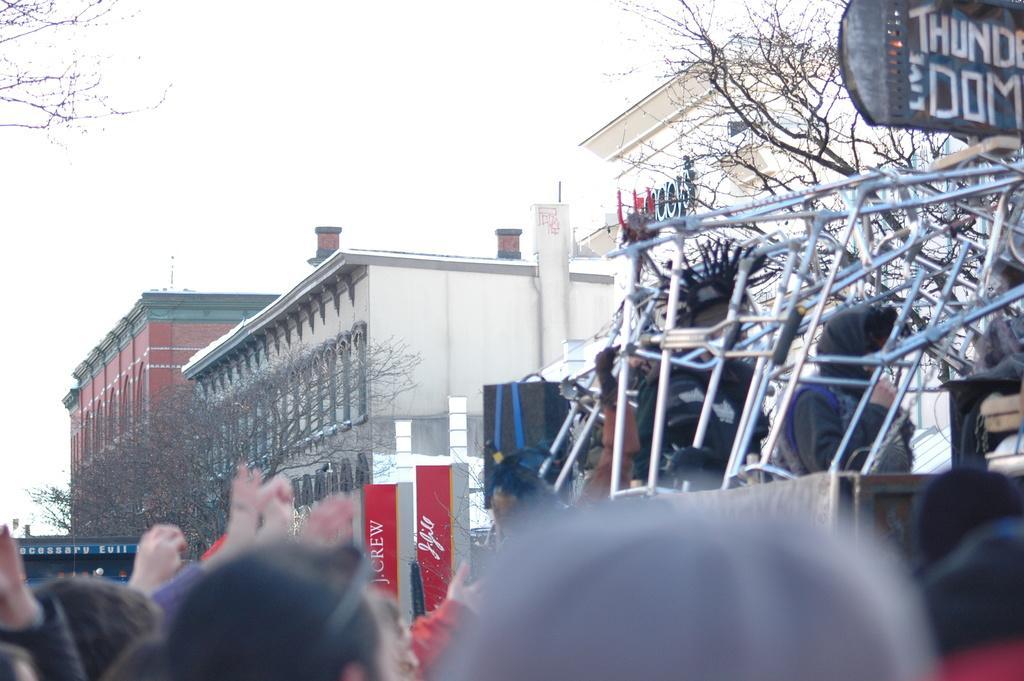Describe this image in one or two sentences. In this picture we can see a group of people, rods, buildings, trees, name boards, banners and in the background we can see the sky. 